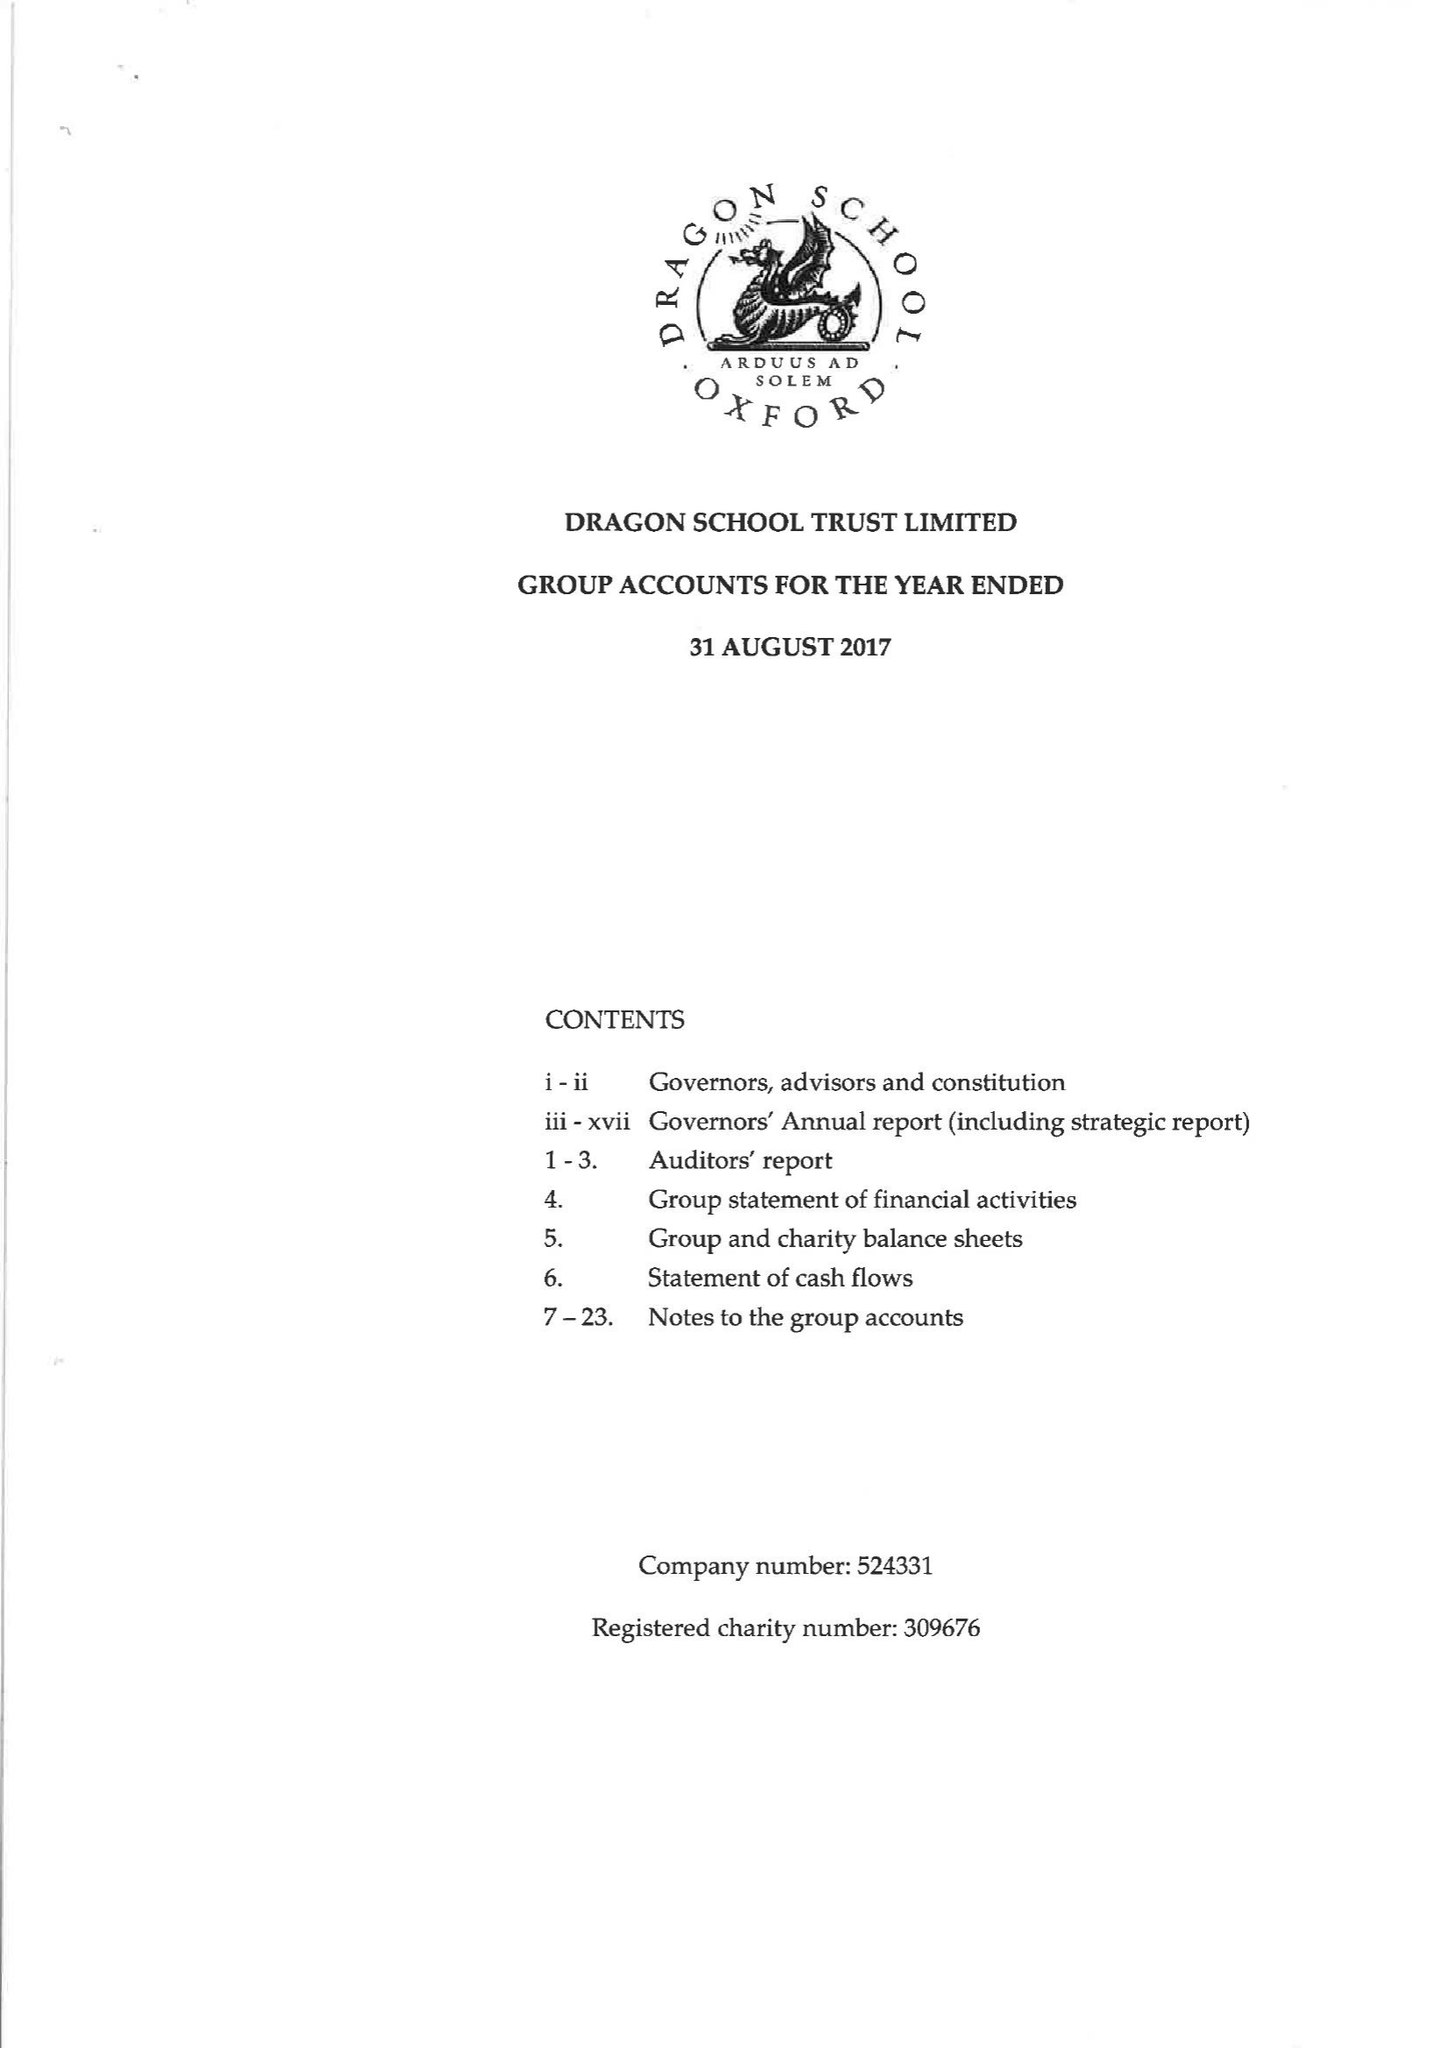What is the value for the charity_number?
Answer the question using a single word or phrase. 309676 